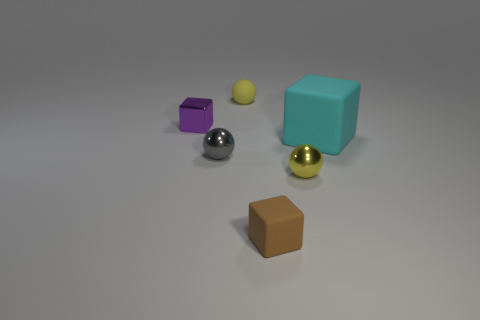Add 1 small rubber blocks. How many objects exist? 7 Subtract 0 yellow cylinders. How many objects are left? 6 Subtract all cyan rubber cubes. Subtract all big cyan cubes. How many objects are left? 4 Add 4 cyan matte cubes. How many cyan matte cubes are left? 5 Add 1 large cyan cubes. How many large cyan cubes exist? 2 